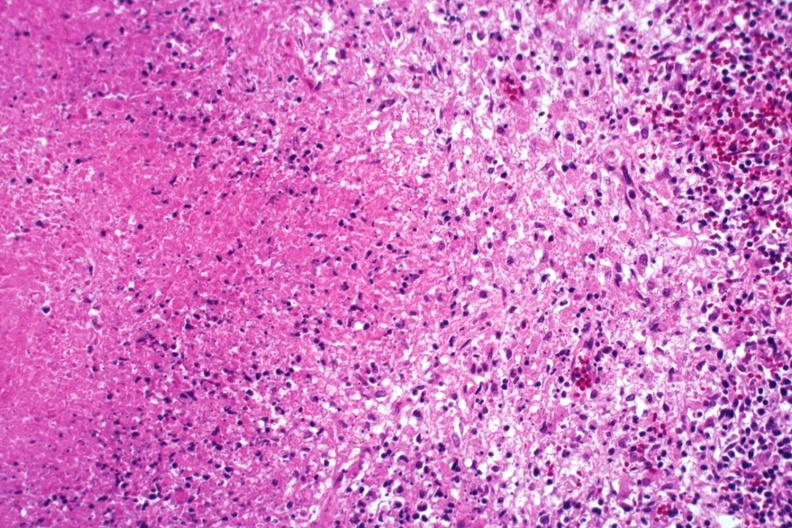what is present?
Answer the question using a single word or phrase. Lymph node 